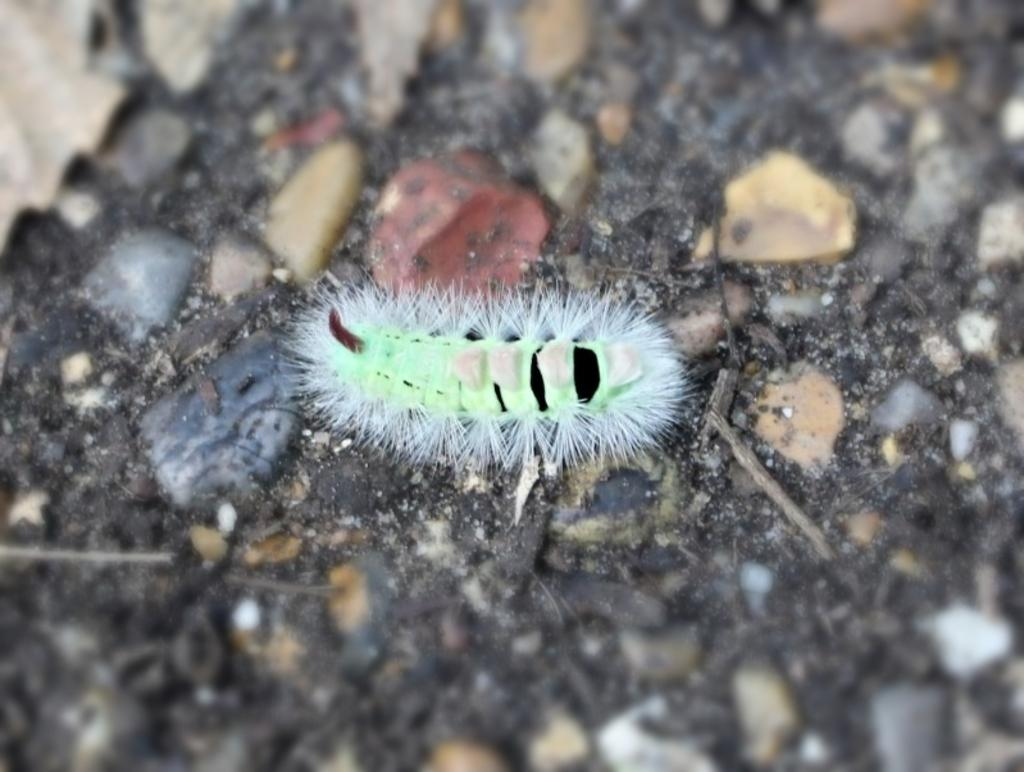What type of creature can be seen in the image? There is an insect in the image. Where is the insect located in the image? The insect is on the ground in the image. What else can be seen on the ground in the image? There are stones on the ground in the image. Can you describe the quality of the image? The image is blurred. How many levels of space are visible in the image? There is no reference to space or levels in the image; it features an insect on the ground with stones. 